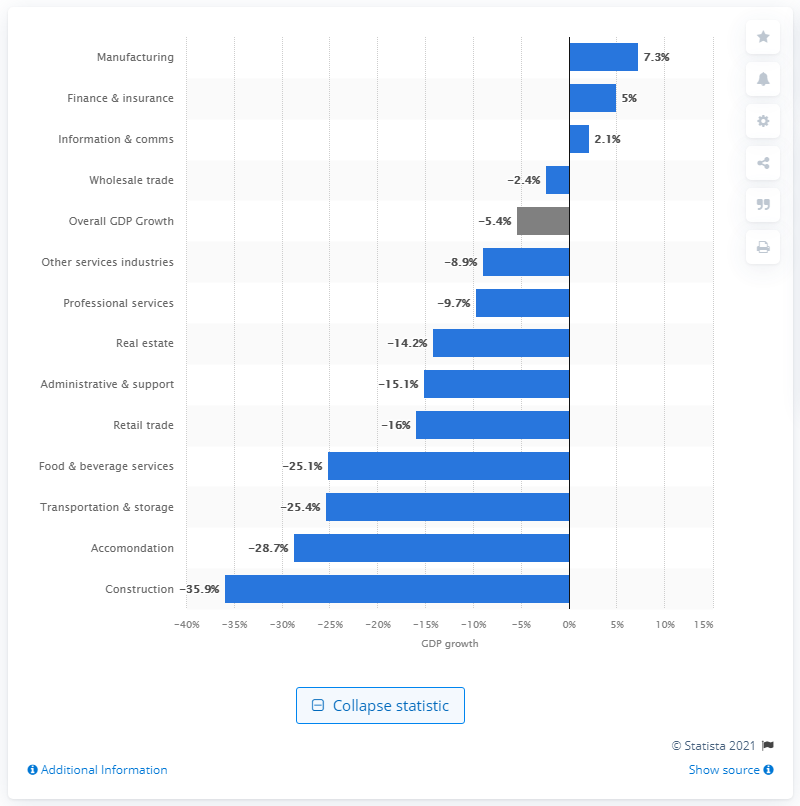Draw attention to some important aspects in this diagram. In 2020, the growth rate of the manufacturing sector in Singapore was 7.3%. 